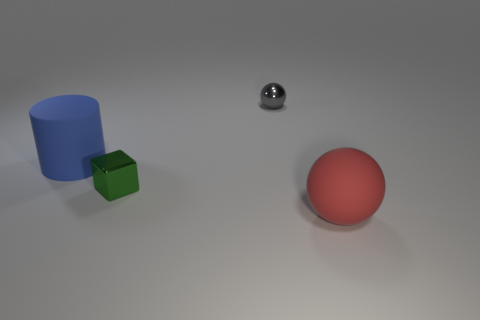How many shiny objects are either red things or small green cylinders? 0 